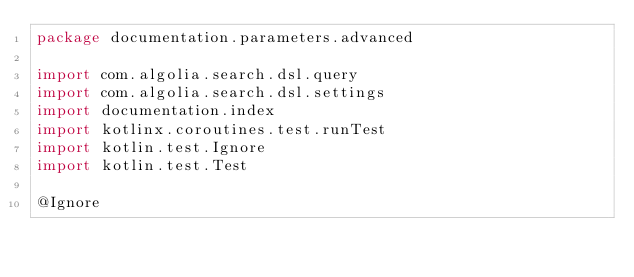<code> <loc_0><loc_0><loc_500><loc_500><_Kotlin_>package documentation.parameters.advanced

import com.algolia.search.dsl.query
import com.algolia.search.dsl.settings
import documentation.index
import kotlinx.coroutines.test.runTest
import kotlin.test.Ignore
import kotlin.test.Test

@Ignore</code> 